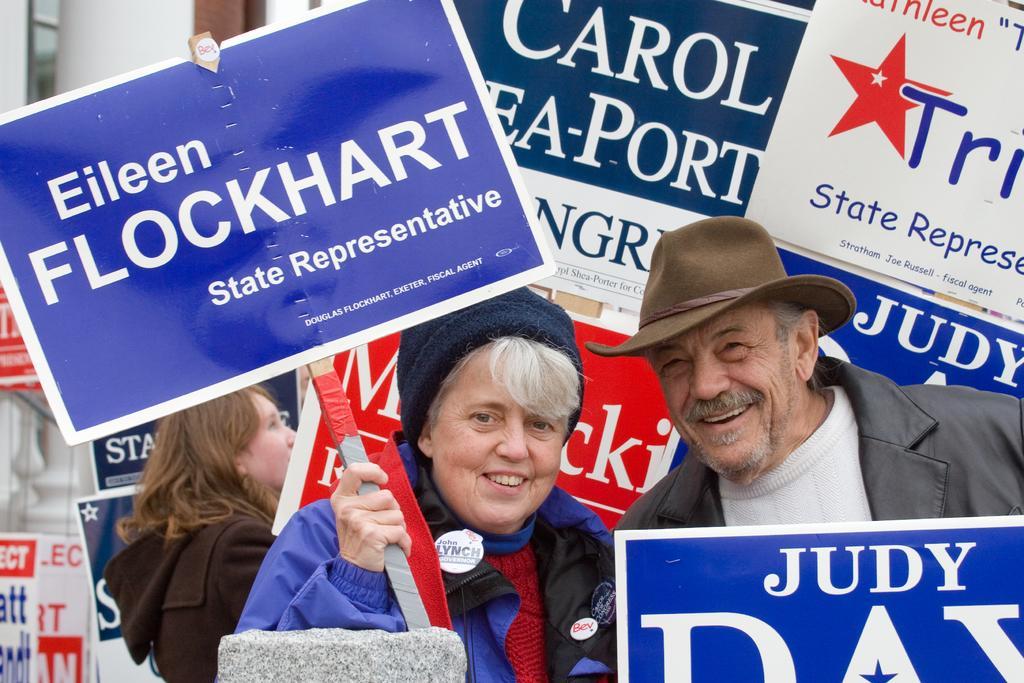Please provide a concise description of this image. In this image we can see some people. In that a woman is holding a board. We can also see some boards with some text on them. In the foreground we can see a stone. 